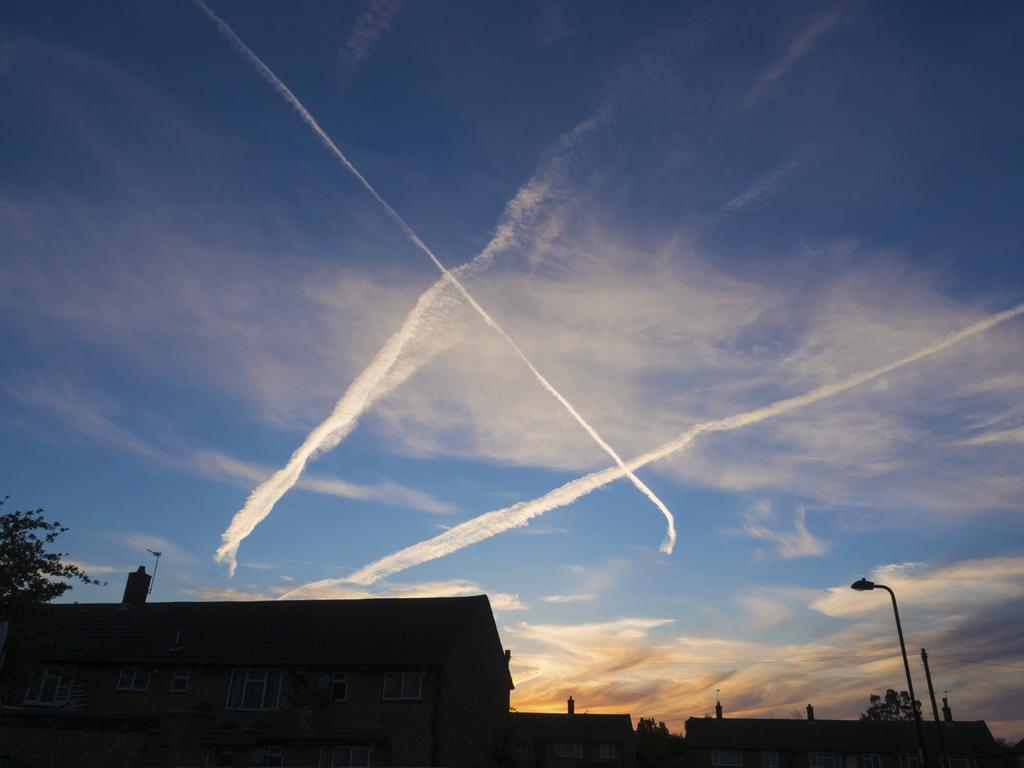Could you give a brief overview of what you see in this image? In the picture I can see the houses at the bottom of the image. I can see the windows of the houses. I can see a light pole on the bottom right side of the picture. There are clouds in the sky. I can see the trees in the picture. 